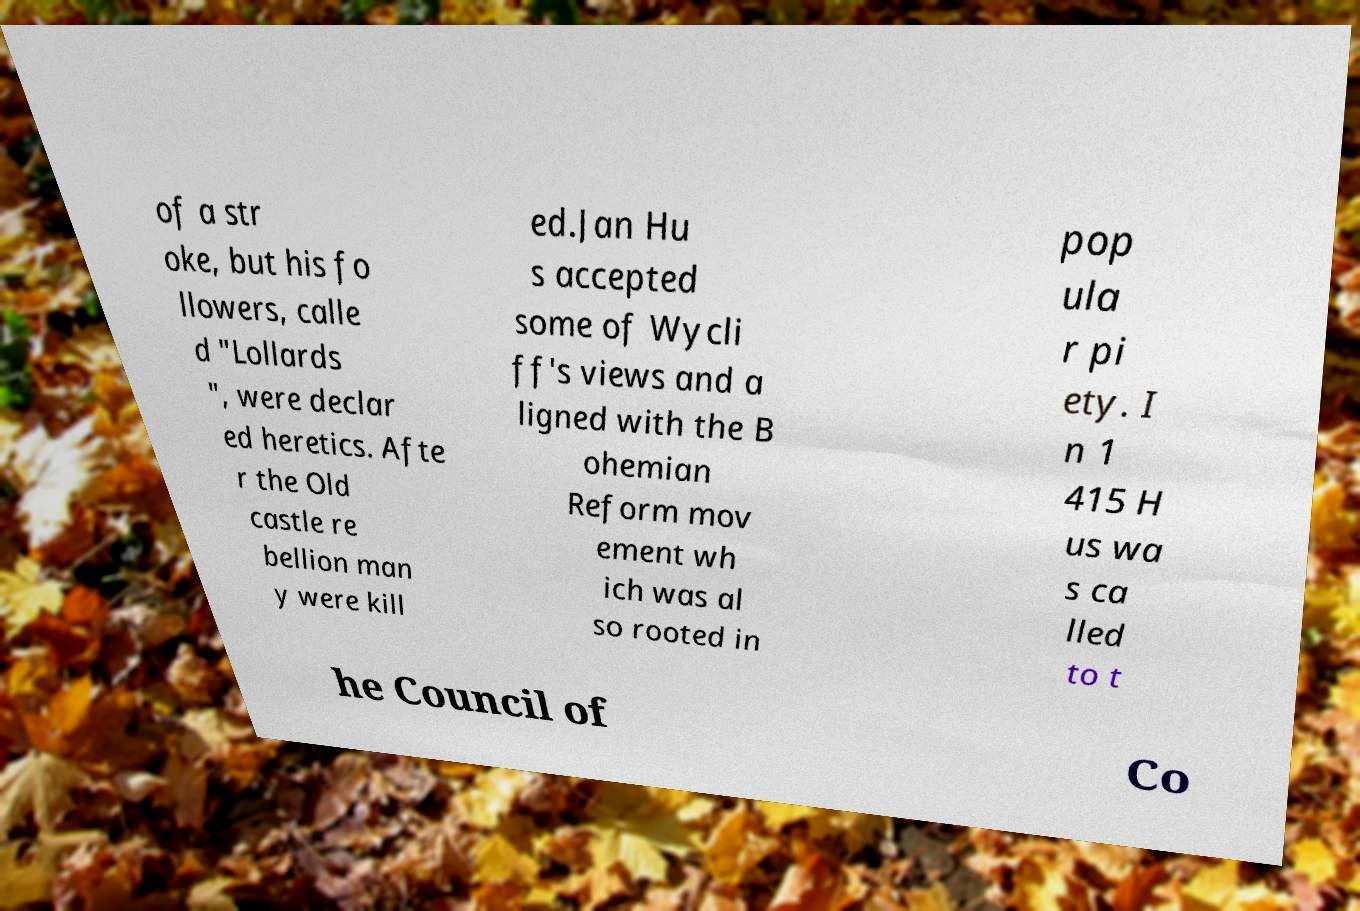Can you accurately transcribe the text from the provided image for me? of a str oke, but his fo llowers, calle d "Lollards ", were declar ed heretics. Afte r the Old castle re bellion man y were kill ed.Jan Hu s accepted some of Wycli ff's views and a ligned with the B ohemian Reform mov ement wh ich was al so rooted in pop ula r pi ety. I n 1 415 H us wa s ca lled to t he Council of Co 